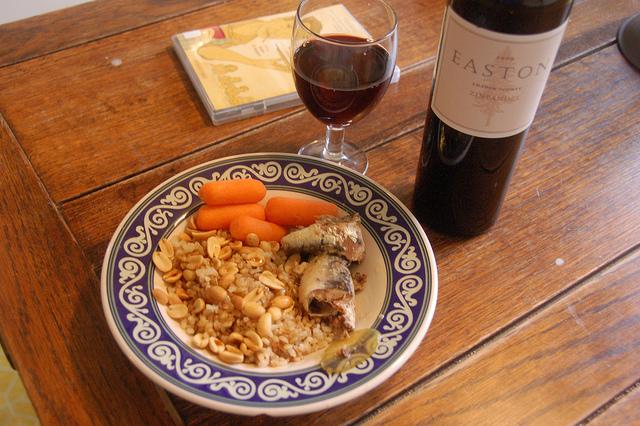What kind of wine has been poured?
Write a very short answer. Red. What is orange on the plate?
Answer briefly. Carrots. Is the glass empty?
Write a very short answer. No. What material is the table?
Answer briefly. Wood. 